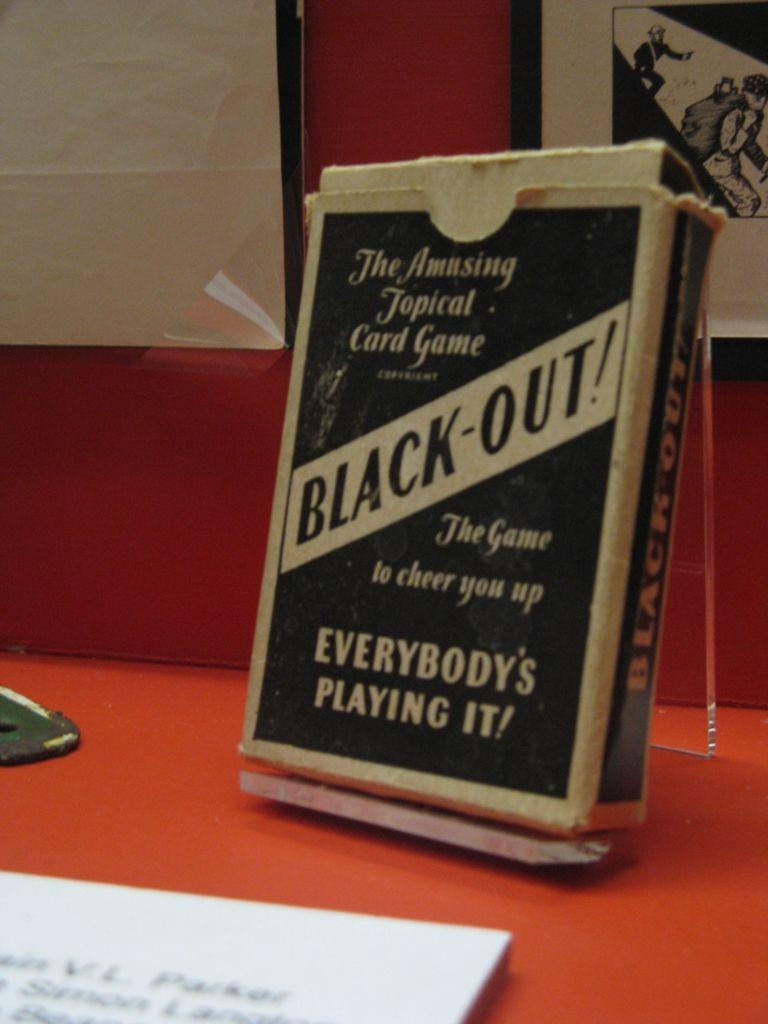<image>
Write a terse but informative summary of the picture. Black-Out is a game that cheers people up. 